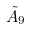<formula> <loc_0><loc_0><loc_500><loc_500>\tilde { A } _ { 9 }</formula> 